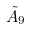<formula> <loc_0><loc_0><loc_500><loc_500>\tilde { A } _ { 9 }</formula> 